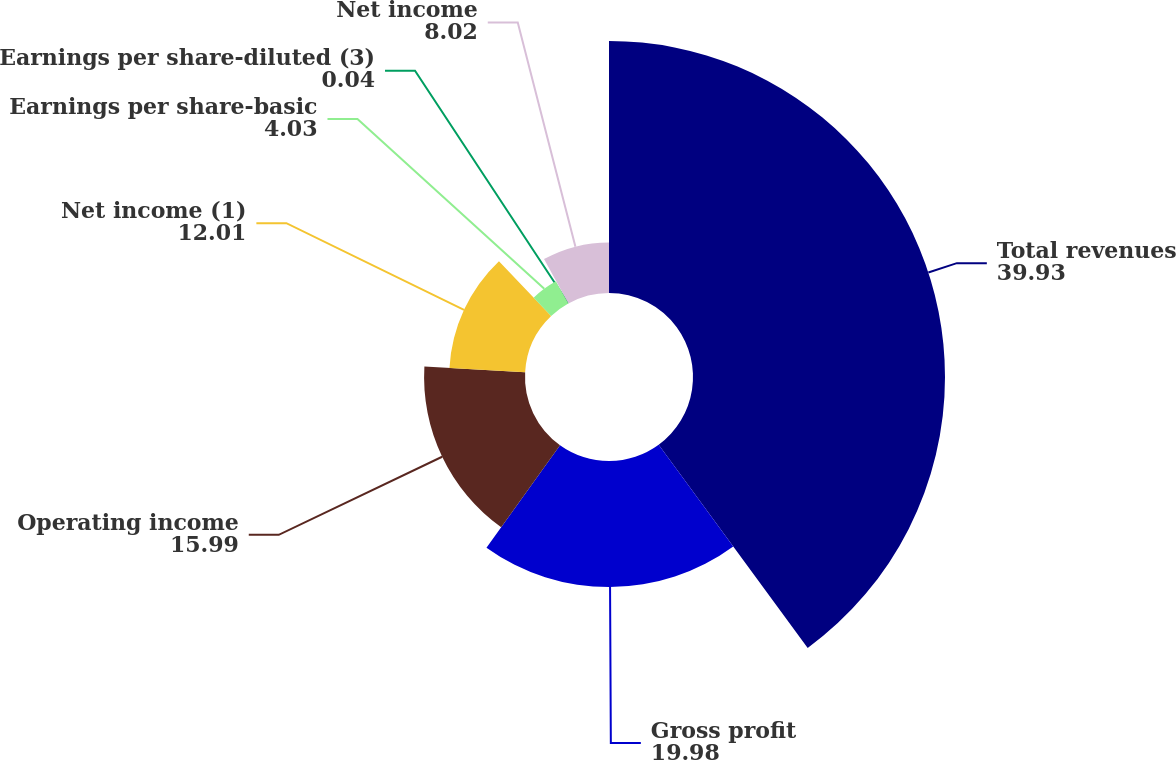Convert chart to OTSL. <chart><loc_0><loc_0><loc_500><loc_500><pie_chart><fcel>Total revenues<fcel>Gross profit<fcel>Operating income<fcel>Net income (1)<fcel>Earnings per share-basic<fcel>Earnings per share-diluted (3)<fcel>Net income<nl><fcel>39.93%<fcel>19.98%<fcel>15.99%<fcel>12.01%<fcel>4.03%<fcel>0.04%<fcel>8.02%<nl></chart> 